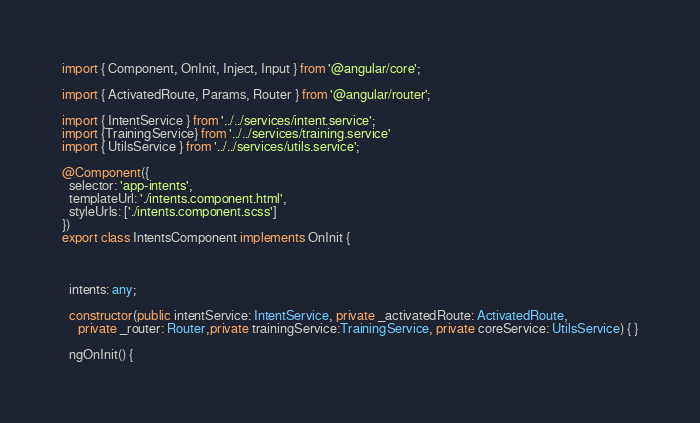<code> <loc_0><loc_0><loc_500><loc_500><_TypeScript_>import { Component, OnInit, Inject, Input } from '@angular/core';

import { ActivatedRoute, Params, Router } from '@angular/router';

import { IntentService } from '../../services/intent.service';
import {TrainingService} from '../../services/training.service'
import { UtilsService } from '../../services/utils.service';

@Component({
  selector: 'app-intents',
  templateUrl: './intents.component.html',
  styleUrls: ['./intents.component.scss']
})
export class IntentsComponent implements OnInit {



  intents: any;

  constructor(public intentService: IntentService, private _activatedRoute: ActivatedRoute,
     private _router: Router,private trainingService:TrainingService, private coreService: UtilsService) { }

  ngOnInit() {
</code> 